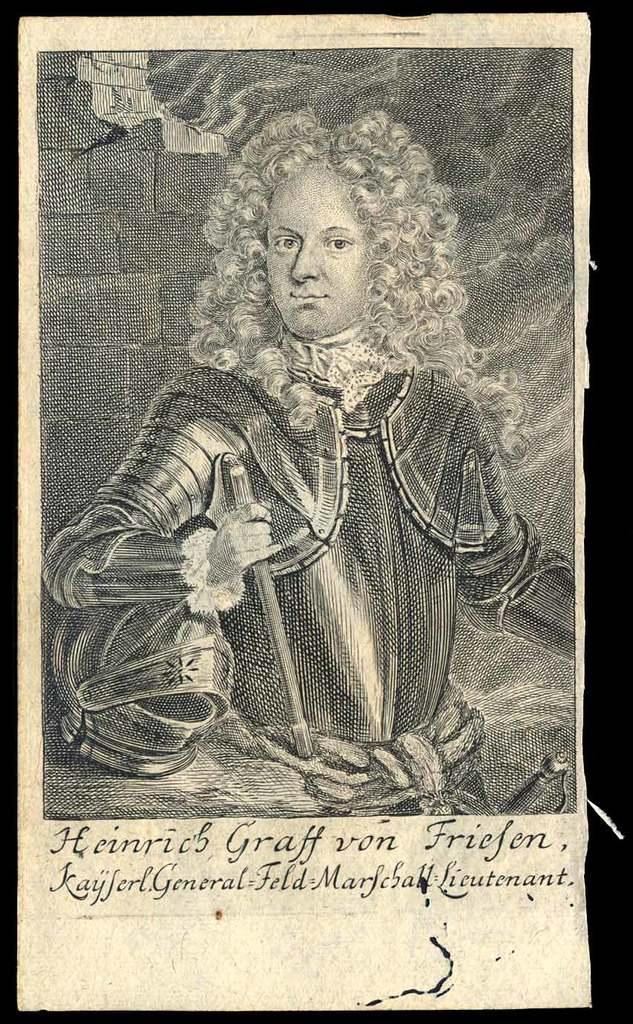What is the main subject of the image? The main subject of the image is a page of a book. What can be seen on the page? The page contains an image of a person and text written on it. What suggestion does the person in the image make about the best measure of knowledge? There is no suggestion or measure of knowledge present in the image; it only contains an image of a person and text written on the page. 